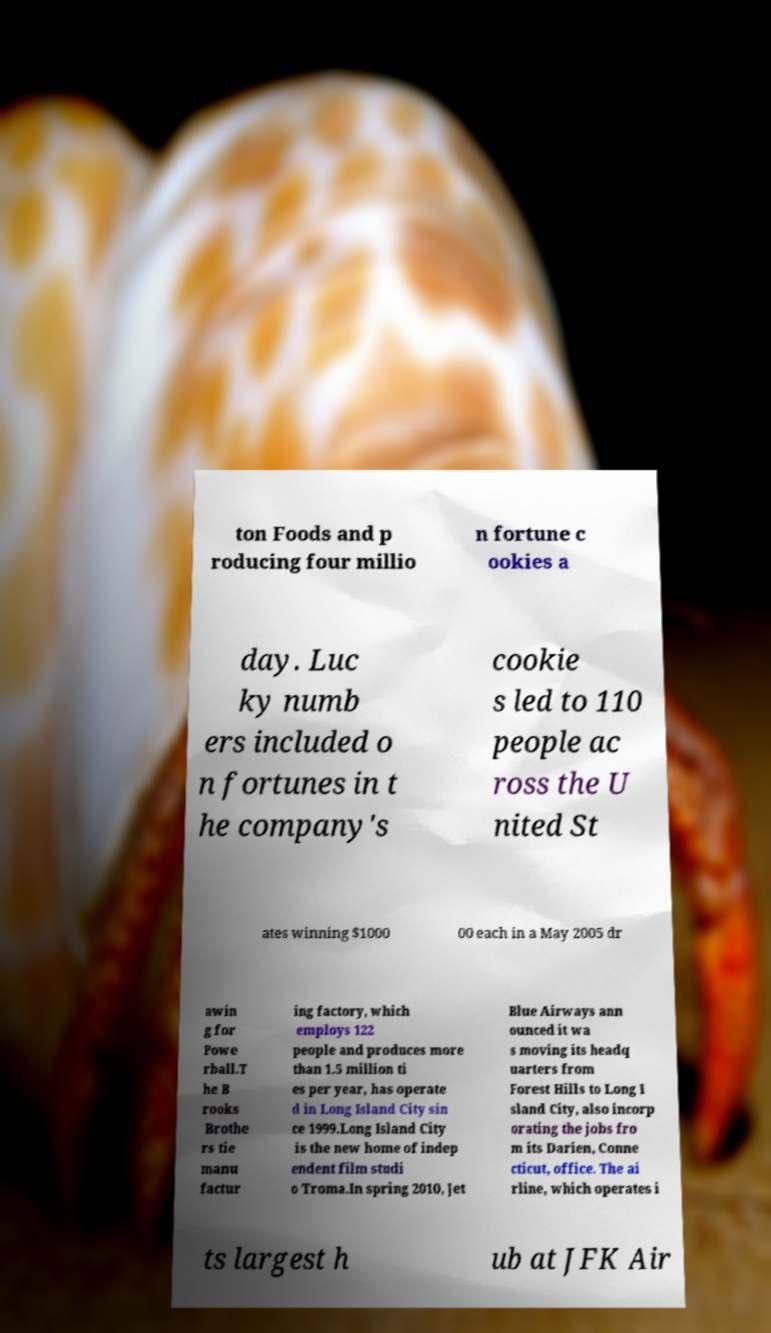Could you extract and type out the text from this image? ton Foods and p roducing four millio n fortune c ookies a day. Luc ky numb ers included o n fortunes in t he company's cookie s led to 110 people ac ross the U nited St ates winning $1000 00 each in a May 2005 dr awin g for Powe rball.T he B rooks Brothe rs tie manu factur ing factory, which employs 122 people and produces more than 1.5 million ti es per year, has operate d in Long Island City sin ce 1999.Long Island City is the new home of indep endent film studi o Troma.In spring 2010, Jet Blue Airways ann ounced it wa s moving its headq uarters from Forest Hills to Long I sland City, also incorp orating the jobs fro m its Darien, Conne cticut, office. The ai rline, which operates i ts largest h ub at JFK Air 